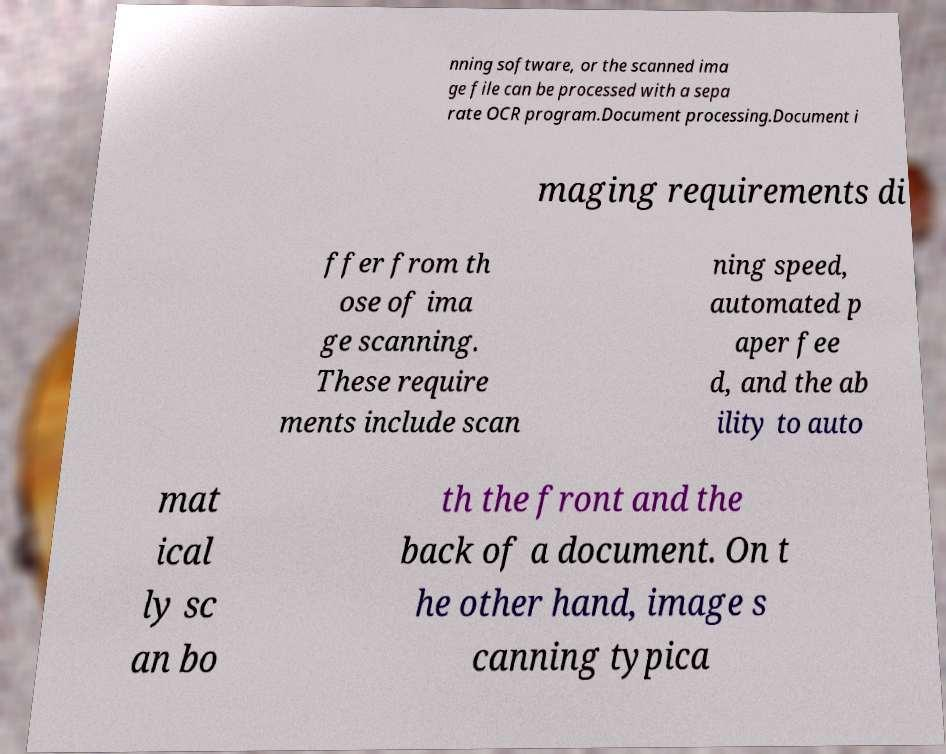Can you read and provide the text displayed in the image?This photo seems to have some interesting text. Can you extract and type it out for me? nning software, or the scanned ima ge file can be processed with a sepa rate OCR program.Document processing.Document i maging requirements di ffer from th ose of ima ge scanning. These require ments include scan ning speed, automated p aper fee d, and the ab ility to auto mat ical ly sc an bo th the front and the back of a document. On t he other hand, image s canning typica 